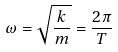Convert formula to latex. <formula><loc_0><loc_0><loc_500><loc_500>\omega = \sqrt { \frac { k } { m } } = \frac { 2 \pi } { T }</formula> 